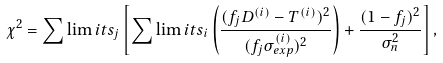Convert formula to latex. <formula><loc_0><loc_0><loc_500><loc_500>\chi ^ { 2 } = \sum \lim i t s _ { j } \left [ \sum \lim i t s _ { i } \left ( \frac { ( f _ { j } D ^ { ( i ) } - T ^ { ( i ) } ) ^ { 2 } } { ( f _ { j } \sigma _ { e x p } ^ { ( i ) } ) ^ { 2 } } \right ) + \frac { ( 1 - f _ { j } ) ^ { 2 } } { \sigma _ { n } ^ { 2 } } \right ] ,</formula> 